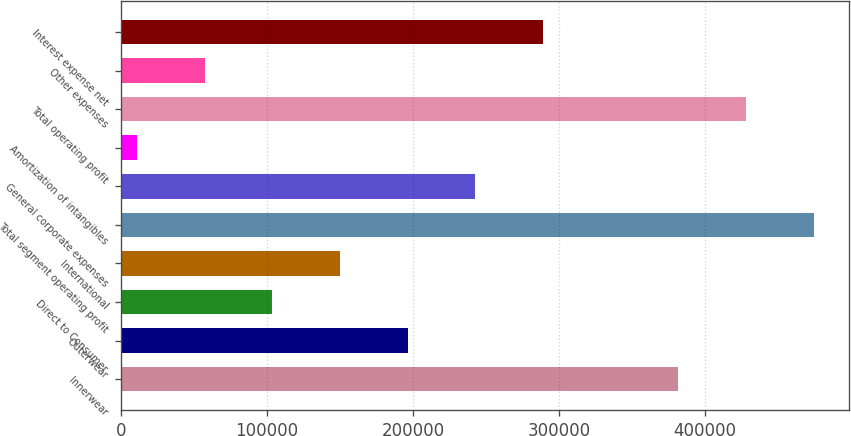Convert chart to OTSL. <chart><loc_0><loc_0><loc_500><loc_500><bar_chart><fcel>Innerwear<fcel>Outerwear<fcel>Direct to Consumer<fcel>International<fcel>Total segment operating profit<fcel>General corporate expenses<fcel>Amortization of intangibles<fcel>Total operating profit<fcel>Other expenses<fcel>Interest expense net<nl><fcel>381841<fcel>196306<fcel>103538<fcel>149922<fcel>474608<fcel>242690<fcel>10771<fcel>428224<fcel>57154.7<fcel>289073<nl></chart> 